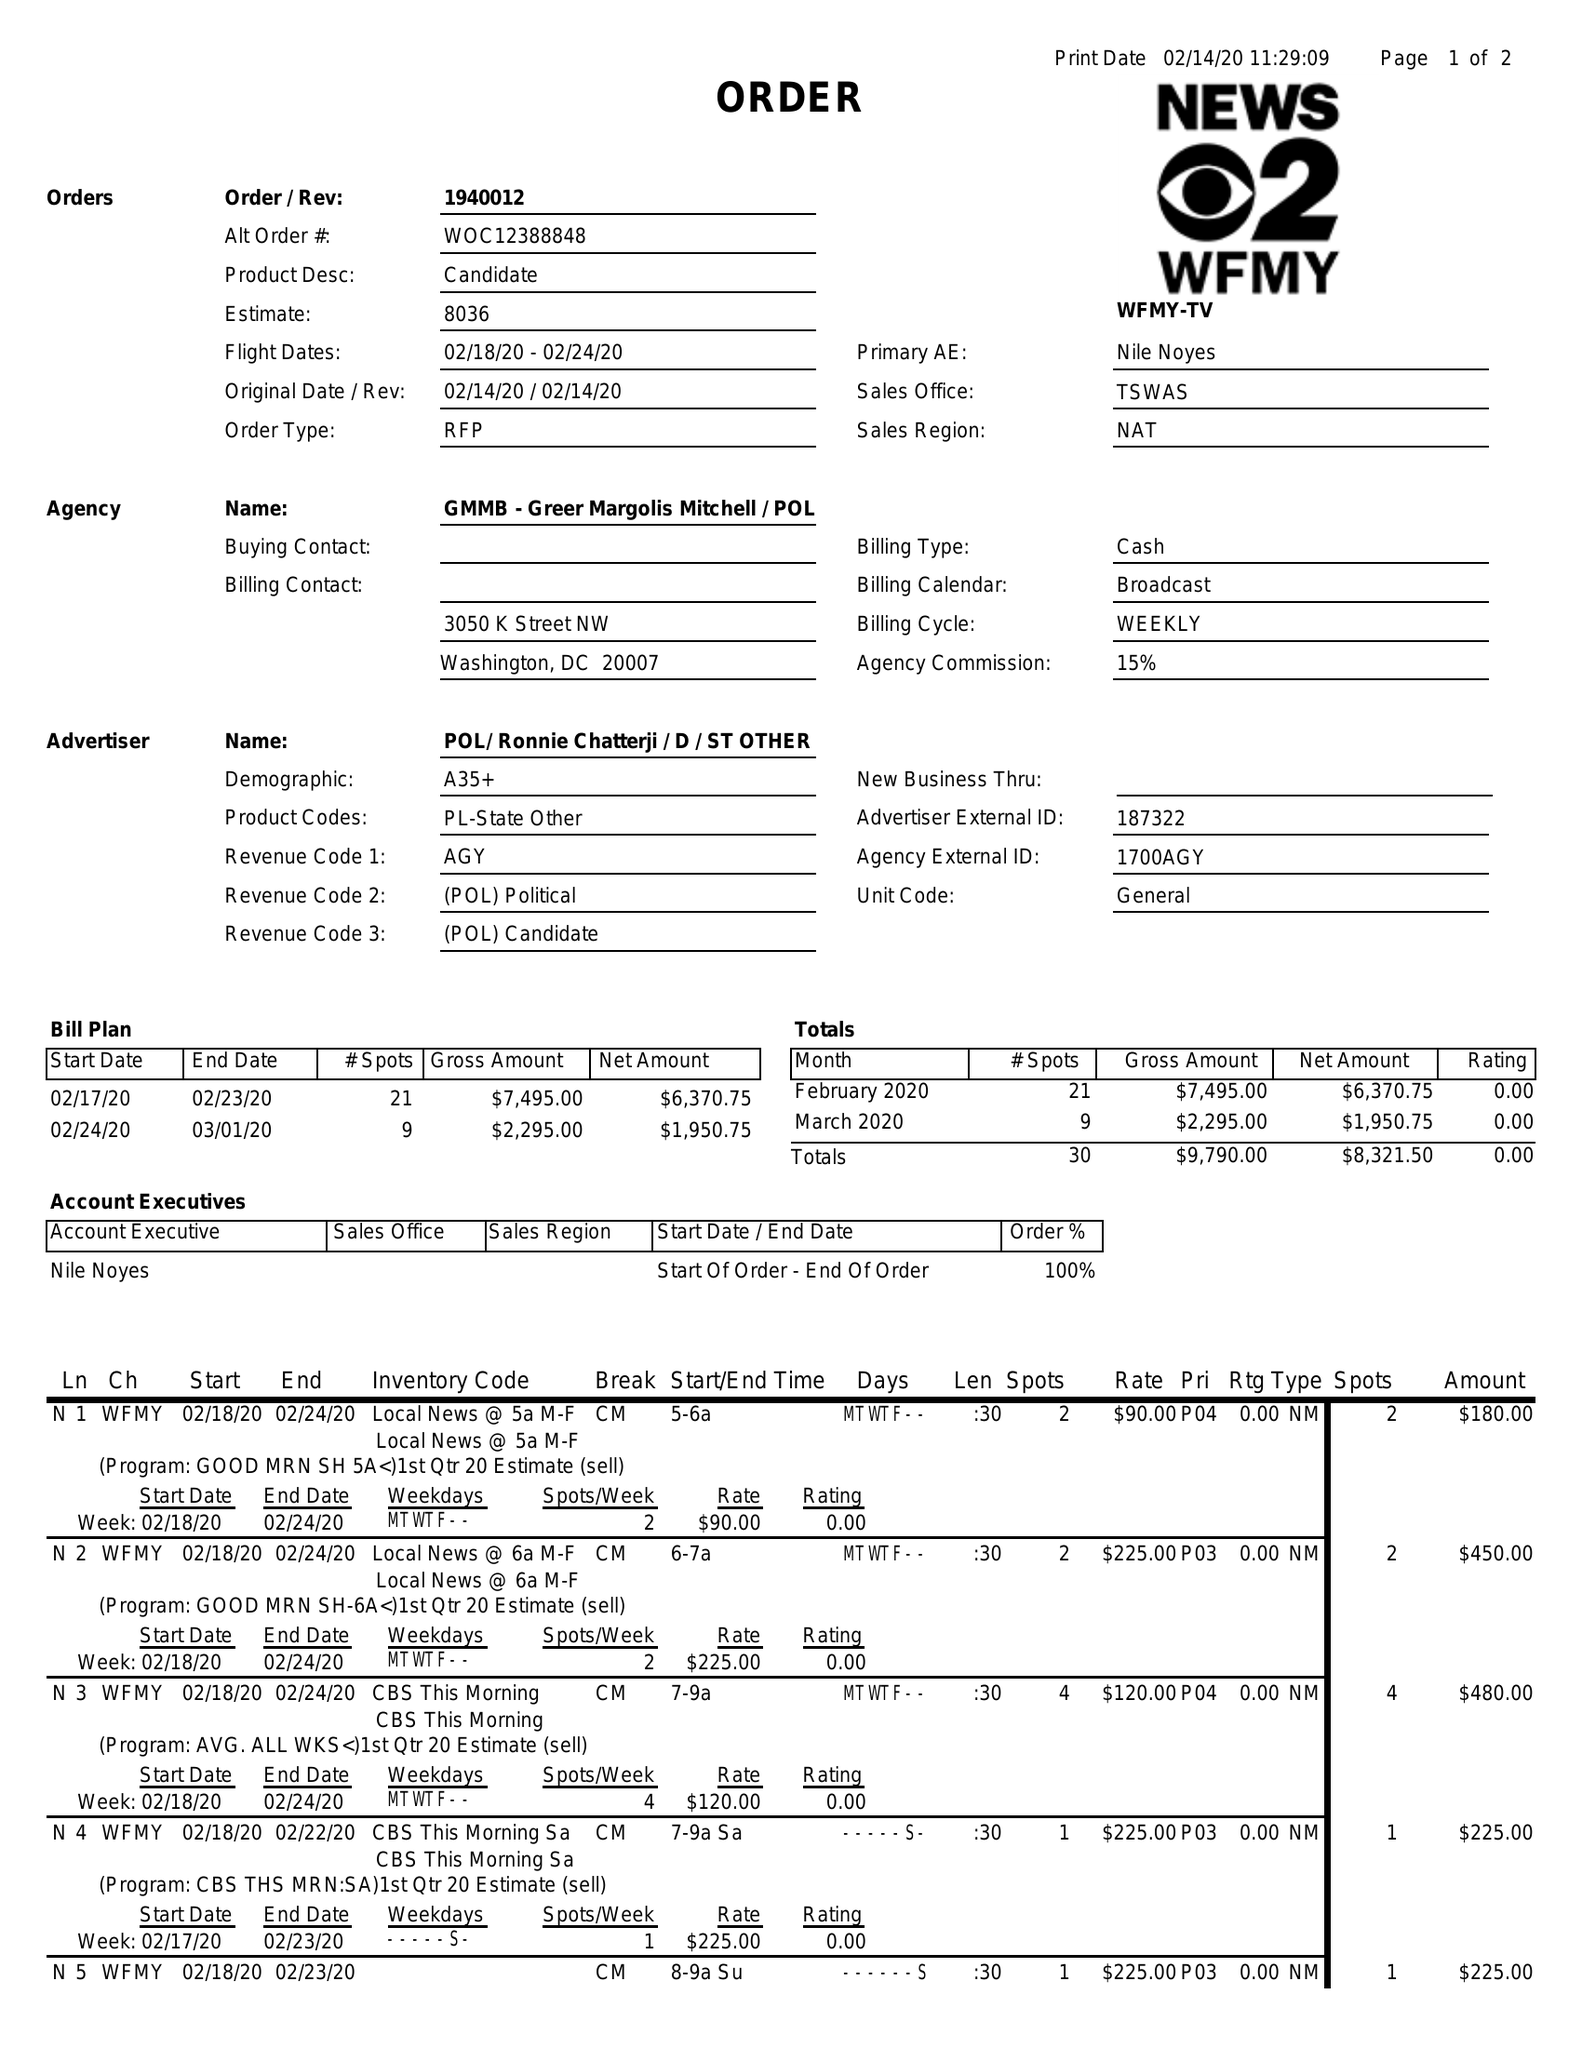What is the value for the flight_to?
Answer the question using a single word or phrase. 02/24/20 